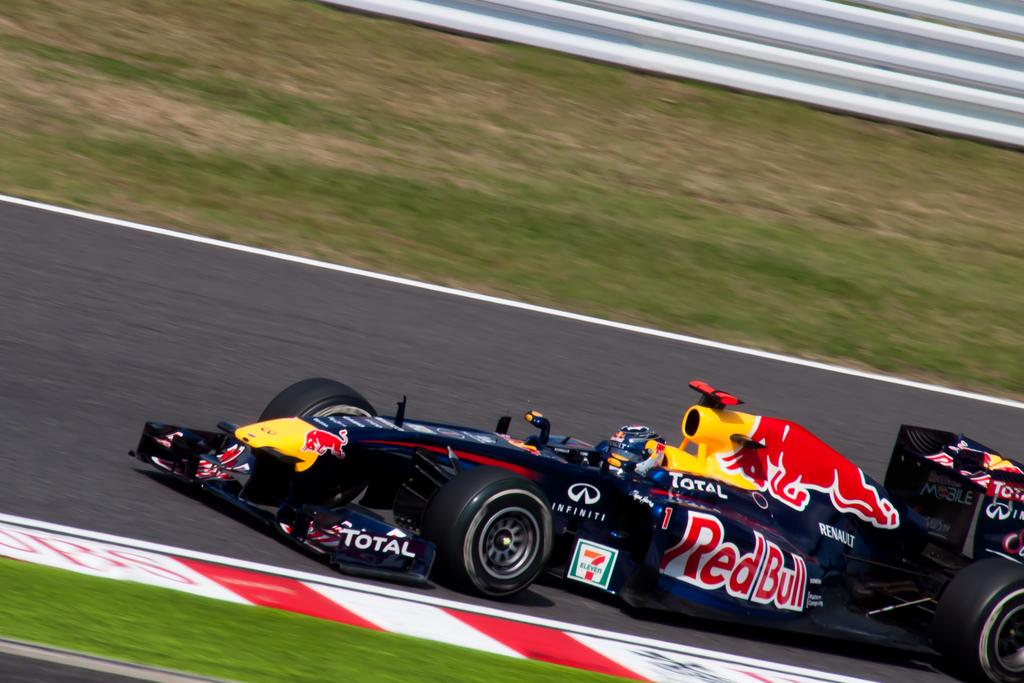What is the main subject of the image? The main subject of the image is a racing car. What color is the racing car? The racing car is black in color. Where is the racing car located in the image? The racing car is on the road. What type of flowers can be seen in the office in the image? There is no office or flowers present in the image; it features a black racing car on the road. 